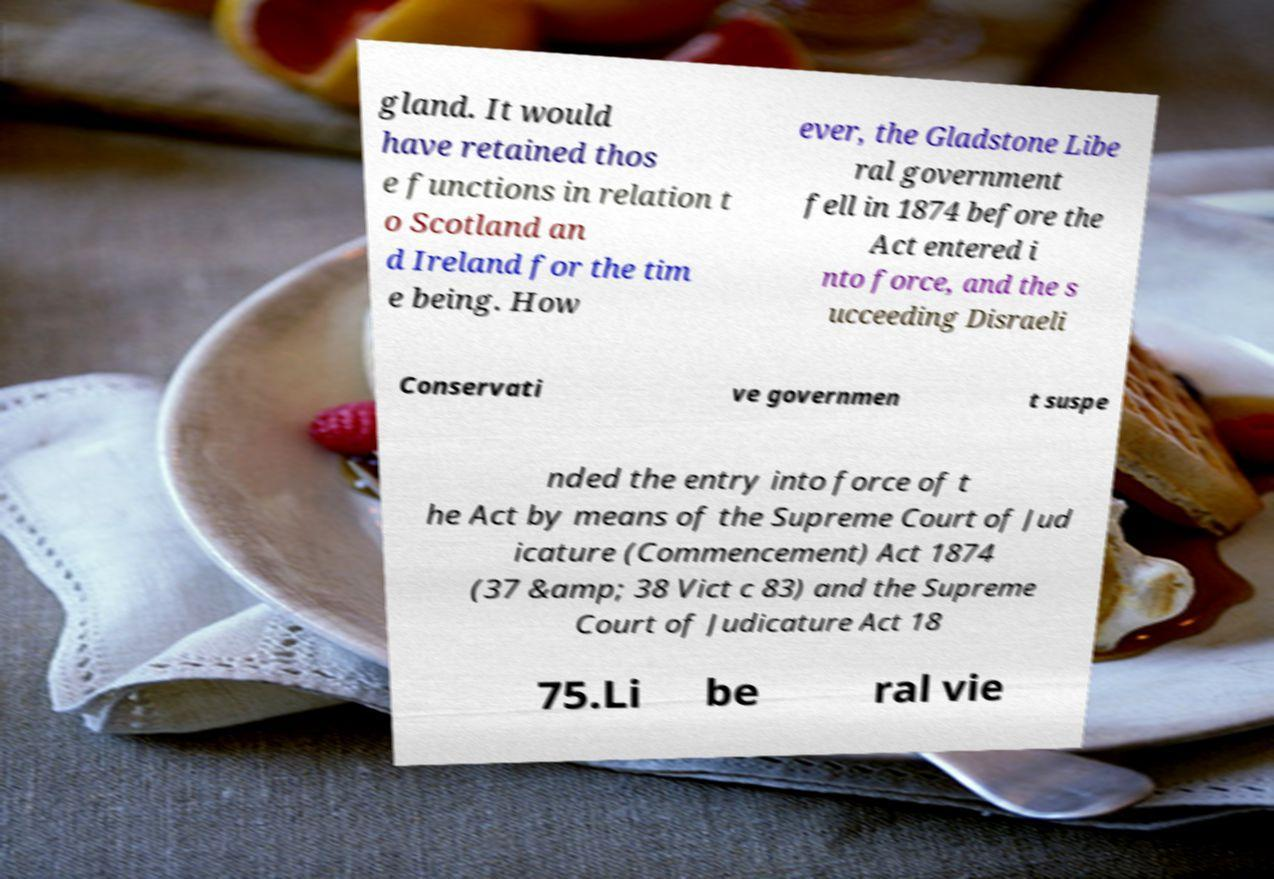What messages or text are displayed in this image? I need them in a readable, typed format. gland. It would have retained thos e functions in relation t o Scotland an d Ireland for the tim e being. How ever, the Gladstone Libe ral government fell in 1874 before the Act entered i nto force, and the s ucceeding Disraeli Conservati ve governmen t suspe nded the entry into force of t he Act by means of the Supreme Court of Jud icature (Commencement) Act 1874 (37 &amp; 38 Vict c 83) and the Supreme Court of Judicature Act 18 75.Li be ral vie 